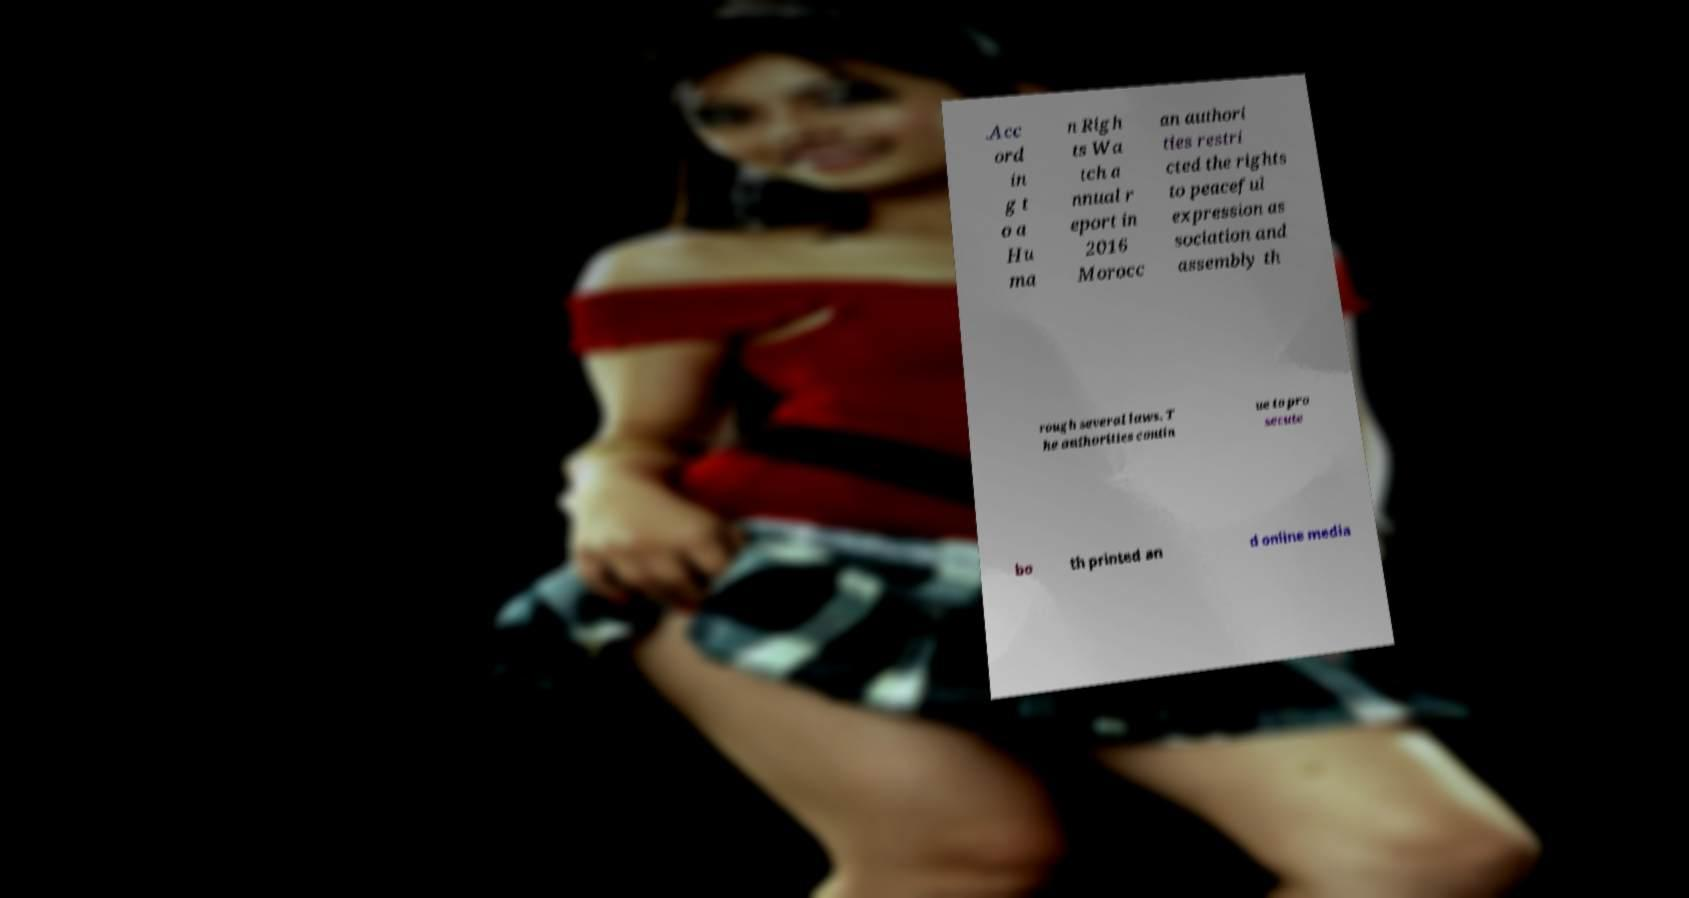There's text embedded in this image that I need extracted. Can you transcribe it verbatim? .Acc ord in g t o a Hu ma n Righ ts Wa tch a nnual r eport in 2016 Morocc an authori ties restri cted the rights to peaceful expression as sociation and assembly th rough several laws. T he authorities contin ue to pro secute bo th printed an d online media 